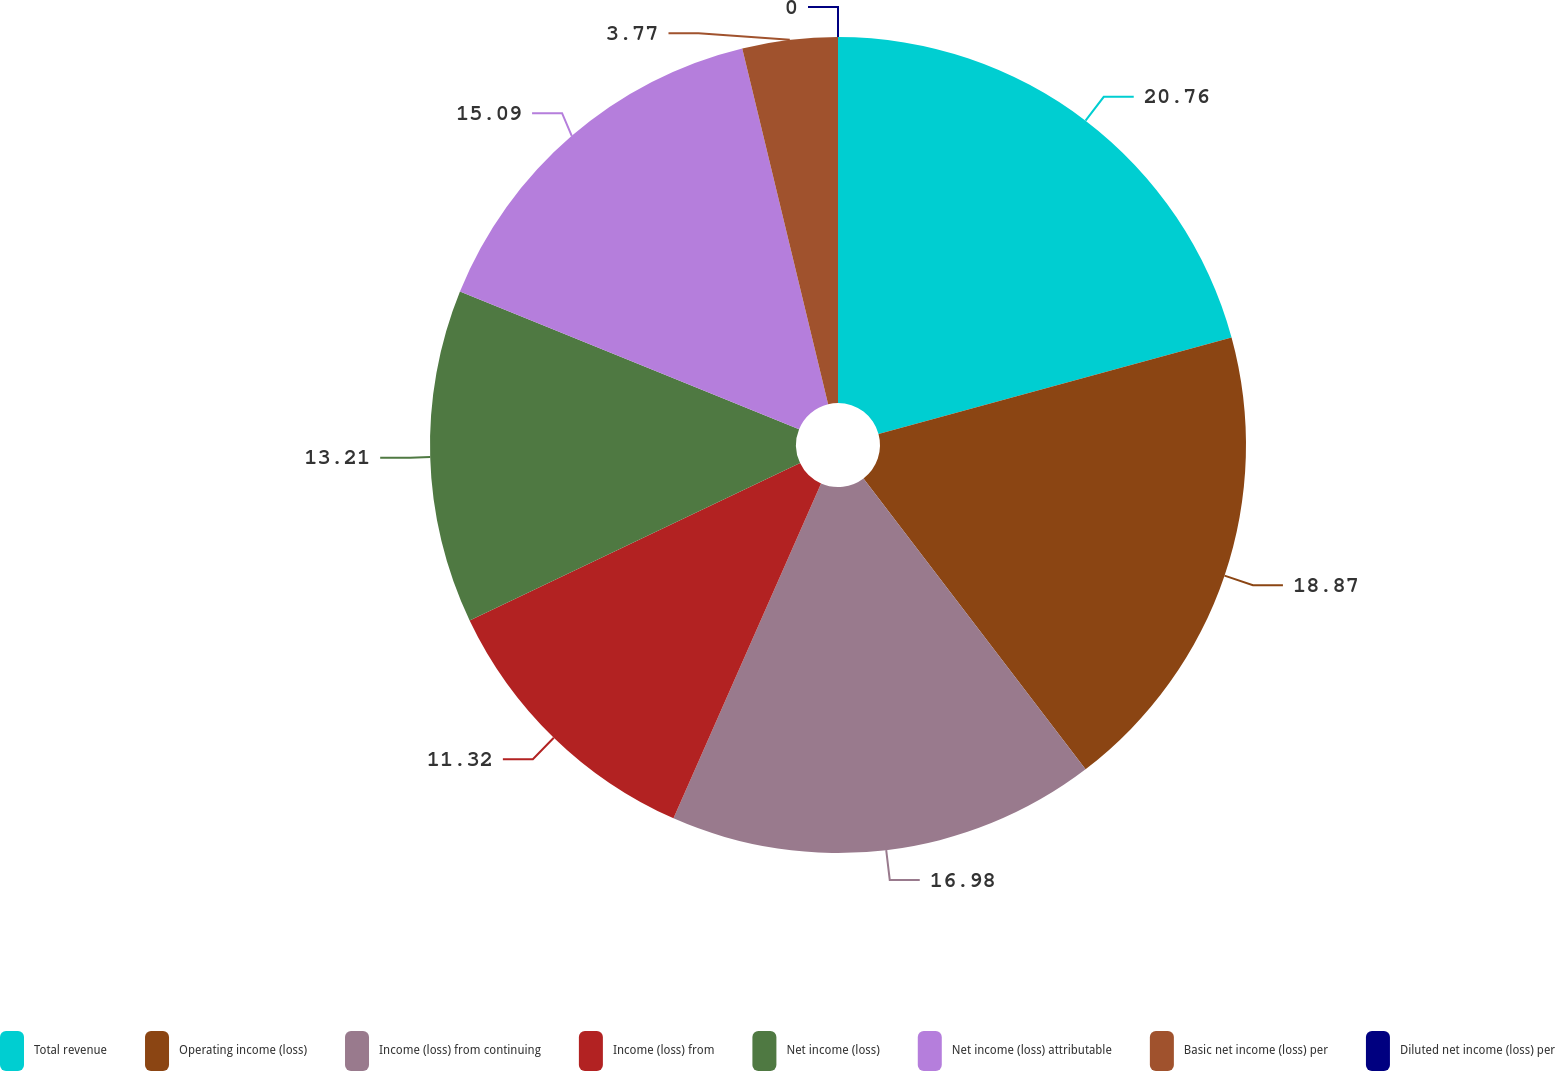Convert chart to OTSL. <chart><loc_0><loc_0><loc_500><loc_500><pie_chart><fcel>Total revenue<fcel>Operating income (loss)<fcel>Income (loss) from continuing<fcel>Income (loss) from<fcel>Net income (loss)<fcel>Net income (loss) attributable<fcel>Basic net income (loss) per<fcel>Diluted net income (loss) per<nl><fcel>20.75%<fcel>18.87%<fcel>16.98%<fcel>11.32%<fcel>13.21%<fcel>15.09%<fcel>3.77%<fcel>0.0%<nl></chart> 